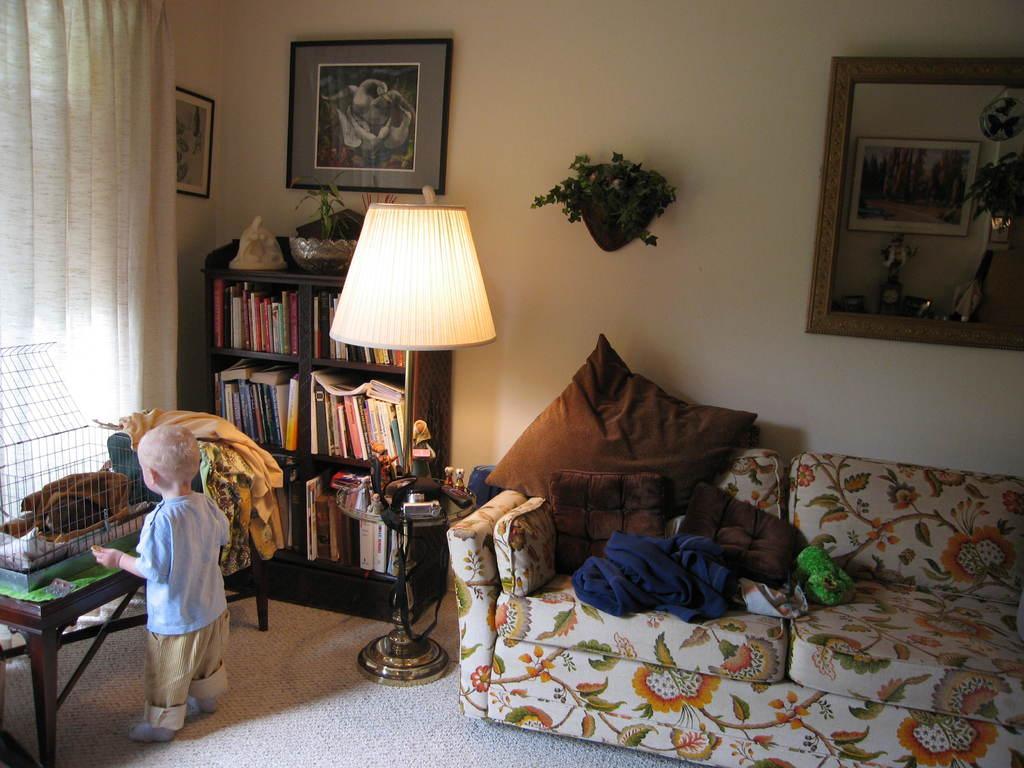How would you summarize this image in a sentence or two? This image consists of a room,a Mirror on the frame, on the right side, sofa, cushions, a kid on the left side, bookshelf with books, a light in the middle and a photo frame on the top, a curtain on the left side. 